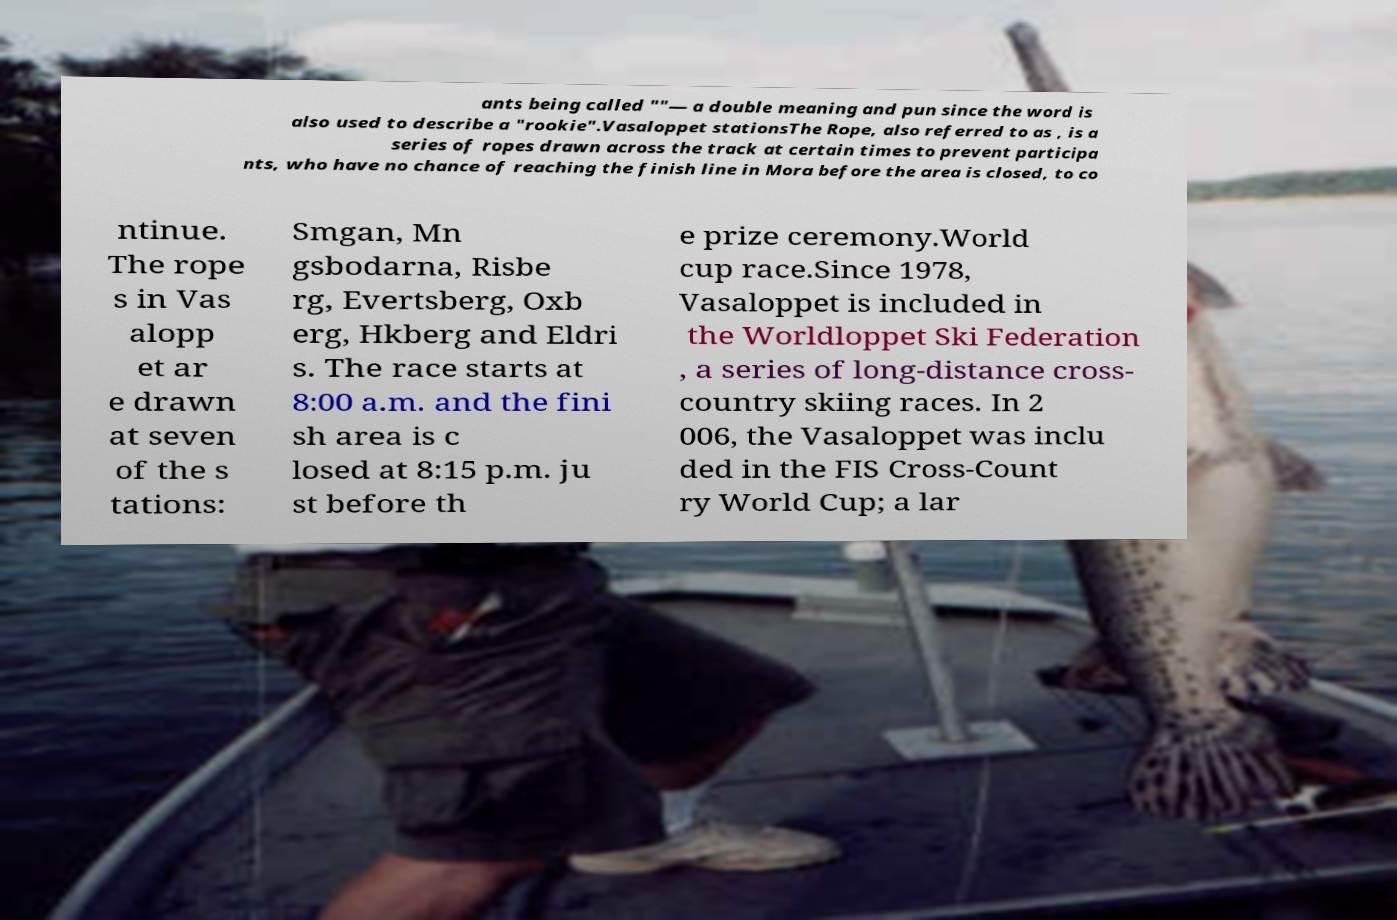What messages or text are displayed in this image? I need them in a readable, typed format. ants being called ""— a double meaning and pun since the word is also used to describe a "rookie".Vasaloppet stationsThe Rope, also referred to as , is a series of ropes drawn across the track at certain times to prevent participa nts, who have no chance of reaching the finish line in Mora before the area is closed, to co ntinue. The rope s in Vas alopp et ar e drawn at seven of the s tations: Smgan, Mn gsbodarna, Risbe rg, Evertsberg, Oxb erg, Hkberg and Eldri s. The race starts at 8:00 a.m. and the fini sh area is c losed at 8:15 p.m. ju st before th e prize ceremony.World cup race.Since 1978, Vasaloppet is included in the Worldloppet Ski Federation , a series of long-distance cross- country skiing races. In 2 006, the Vasaloppet was inclu ded in the FIS Cross-Count ry World Cup; a lar 